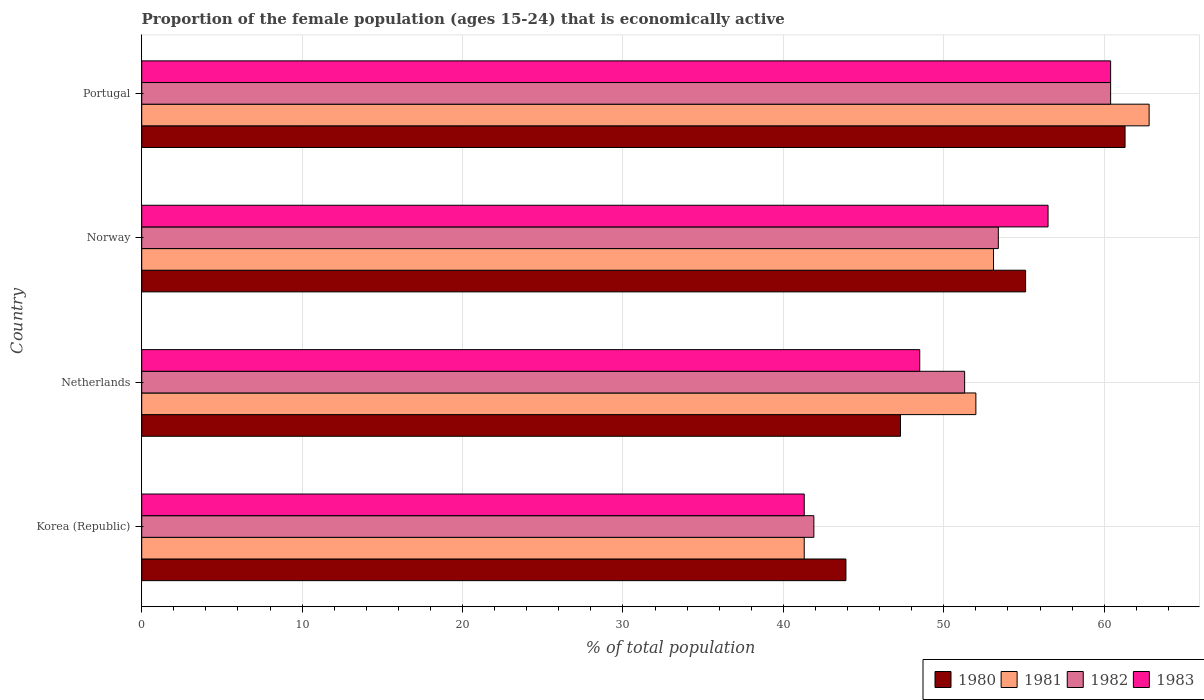How many different coloured bars are there?
Offer a very short reply. 4. Are the number of bars on each tick of the Y-axis equal?
Give a very brief answer. Yes. How many bars are there on the 3rd tick from the top?
Offer a very short reply. 4. What is the label of the 4th group of bars from the top?
Offer a terse response. Korea (Republic). In how many cases, is the number of bars for a given country not equal to the number of legend labels?
Give a very brief answer. 0. What is the proportion of the female population that is economically active in 1982 in Netherlands?
Provide a succinct answer. 51.3. Across all countries, what is the maximum proportion of the female population that is economically active in 1983?
Keep it short and to the point. 60.4. Across all countries, what is the minimum proportion of the female population that is economically active in 1983?
Provide a succinct answer. 41.3. In which country was the proportion of the female population that is economically active in 1981 maximum?
Provide a short and direct response. Portugal. In which country was the proportion of the female population that is economically active in 1980 minimum?
Give a very brief answer. Korea (Republic). What is the total proportion of the female population that is economically active in 1983 in the graph?
Ensure brevity in your answer.  206.7. What is the difference between the proportion of the female population that is economically active in 1983 in Korea (Republic) and that in Netherlands?
Offer a terse response. -7.2. What is the difference between the proportion of the female population that is economically active in 1981 in Portugal and the proportion of the female population that is economically active in 1980 in Korea (Republic)?
Provide a short and direct response. 18.9. What is the average proportion of the female population that is economically active in 1981 per country?
Give a very brief answer. 52.3. What is the difference between the proportion of the female population that is economically active in 1982 and proportion of the female population that is economically active in 1981 in Norway?
Your answer should be compact. 0.3. What is the ratio of the proportion of the female population that is economically active in 1981 in Norway to that in Portugal?
Ensure brevity in your answer.  0.85. Is the proportion of the female population that is economically active in 1980 in Korea (Republic) less than that in Norway?
Provide a short and direct response. Yes. What is the difference between the highest and the second highest proportion of the female population that is economically active in 1980?
Give a very brief answer. 6.2. In how many countries, is the proportion of the female population that is economically active in 1983 greater than the average proportion of the female population that is economically active in 1983 taken over all countries?
Offer a very short reply. 2. What does the 1st bar from the top in Korea (Republic) represents?
Provide a short and direct response. 1983. What does the 2nd bar from the bottom in Portugal represents?
Ensure brevity in your answer.  1981. Is it the case that in every country, the sum of the proportion of the female population that is economically active in 1981 and proportion of the female population that is economically active in 1983 is greater than the proportion of the female population that is economically active in 1980?
Provide a succinct answer. Yes. Are all the bars in the graph horizontal?
Your answer should be very brief. Yes. What is the difference between two consecutive major ticks on the X-axis?
Ensure brevity in your answer.  10. Does the graph contain any zero values?
Your answer should be very brief. No. Where does the legend appear in the graph?
Provide a succinct answer. Bottom right. How many legend labels are there?
Offer a very short reply. 4. How are the legend labels stacked?
Provide a short and direct response. Horizontal. What is the title of the graph?
Keep it short and to the point. Proportion of the female population (ages 15-24) that is economically active. Does "2010" appear as one of the legend labels in the graph?
Provide a short and direct response. No. What is the label or title of the X-axis?
Provide a short and direct response. % of total population. What is the % of total population in 1980 in Korea (Republic)?
Your answer should be compact. 43.9. What is the % of total population in 1981 in Korea (Republic)?
Offer a very short reply. 41.3. What is the % of total population of 1982 in Korea (Republic)?
Your response must be concise. 41.9. What is the % of total population in 1983 in Korea (Republic)?
Your answer should be compact. 41.3. What is the % of total population of 1980 in Netherlands?
Provide a succinct answer. 47.3. What is the % of total population in 1982 in Netherlands?
Your answer should be very brief. 51.3. What is the % of total population in 1983 in Netherlands?
Offer a terse response. 48.5. What is the % of total population in 1980 in Norway?
Keep it short and to the point. 55.1. What is the % of total population in 1981 in Norway?
Provide a short and direct response. 53.1. What is the % of total population in 1982 in Norway?
Keep it short and to the point. 53.4. What is the % of total population in 1983 in Norway?
Your response must be concise. 56.5. What is the % of total population in 1980 in Portugal?
Make the answer very short. 61.3. What is the % of total population in 1981 in Portugal?
Offer a very short reply. 62.8. What is the % of total population in 1982 in Portugal?
Provide a short and direct response. 60.4. What is the % of total population of 1983 in Portugal?
Provide a succinct answer. 60.4. Across all countries, what is the maximum % of total population of 1980?
Your response must be concise. 61.3. Across all countries, what is the maximum % of total population of 1981?
Make the answer very short. 62.8. Across all countries, what is the maximum % of total population in 1982?
Offer a terse response. 60.4. Across all countries, what is the maximum % of total population of 1983?
Ensure brevity in your answer.  60.4. Across all countries, what is the minimum % of total population in 1980?
Give a very brief answer. 43.9. Across all countries, what is the minimum % of total population in 1981?
Offer a terse response. 41.3. Across all countries, what is the minimum % of total population in 1982?
Ensure brevity in your answer.  41.9. Across all countries, what is the minimum % of total population of 1983?
Keep it short and to the point. 41.3. What is the total % of total population in 1980 in the graph?
Provide a succinct answer. 207.6. What is the total % of total population in 1981 in the graph?
Keep it short and to the point. 209.2. What is the total % of total population in 1982 in the graph?
Provide a succinct answer. 207. What is the total % of total population in 1983 in the graph?
Provide a succinct answer. 206.7. What is the difference between the % of total population of 1980 in Korea (Republic) and that in Netherlands?
Offer a terse response. -3.4. What is the difference between the % of total population in 1981 in Korea (Republic) and that in Netherlands?
Provide a succinct answer. -10.7. What is the difference between the % of total population in 1982 in Korea (Republic) and that in Netherlands?
Provide a short and direct response. -9.4. What is the difference between the % of total population of 1983 in Korea (Republic) and that in Netherlands?
Keep it short and to the point. -7.2. What is the difference between the % of total population in 1981 in Korea (Republic) and that in Norway?
Give a very brief answer. -11.8. What is the difference between the % of total population of 1983 in Korea (Republic) and that in Norway?
Your answer should be very brief. -15.2. What is the difference between the % of total population of 1980 in Korea (Republic) and that in Portugal?
Ensure brevity in your answer.  -17.4. What is the difference between the % of total population of 1981 in Korea (Republic) and that in Portugal?
Ensure brevity in your answer.  -21.5. What is the difference between the % of total population in 1982 in Korea (Republic) and that in Portugal?
Give a very brief answer. -18.5. What is the difference between the % of total population in 1983 in Korea (Republic) and that in Portugal?
Keep it short and to the point. -19.1. What is the difference between the % of total population of 1980 in Netherlands and that in Norway?
Offer a terse response. -7.8. What is the difference between the % of total population of 1981 in Netherlands and that in Norway?
Ensure brevity in your answer.  -1.1. What is the difference between the % of total population in 1982 in Netherlands and that in Norway?
Your answer should be very brief. -2.1. What is the difference between the % of total population in 1983 in Netherlands and that in Norway?
Give a very brief answer. -8. What is the difference between the % of total population of 1980 in Netherlands and that in Portugal?
Offer a terse response. -14. What is the difference between the % of total population of 1982 in Netherlands and that in Portugal?
Offer a very short reply. -9.1. What is the difference between the % of total population in 1983 in Netherlands and that in Portugal?
Your answer should be compact. -11.9. What is the difference between the % of total population of 1980 in Norway and that in Portugal?
Your response must be concise. -6.2. What is the difference between the % of total population of 1981 in Norway and that in Portugal?
Offer a terse response. -9.7. What is the difference between the % of total population in 1983 in Norway and that in Portugal?
Keep it short and to the point. -3.9. What is the difference between the % of total population in 1980 in Korea (Republic) and the % of total population in 1982 in Netherlands?
Provide a succinct answer. -7.4. What is the difference between the % of total population in 1982 in Korea (Republic) and the % of total population in 1983 in Netherlands?
Your answer should be very brief. -6.6. What is the difference between the % of total population in 1980 in Korea (Republic) and the % of total population in 1982 in Norway?
Offer a very short reply. -9.5. What is the difference between the % of total population of 1980 in Korea (Republic) and the % of total population of 1983 in Norway?
Offer a very short reply. -12.6. What is the difference between the % of total population of 1981 in Korea (Republic) and the % of total population of 1983 in Norway?
Your answer should be compact. -15.2. What is the difference between the % of total population of 1982 in Korea (Republic) and the % of total population of 1983 in Norway?
Offer a terse response. -14.6. What is the difference between the % of total population in 1980 in Korea (Republic) and the % of total population in 1981 in Portugal?
Offer a terse response. -18.9. What is the difference between the % of total population of 1980 in Korea (Republic) and the % of total population of 1982 in Portugal?
Offer a very short reply. -16.5. What is the difference between the % of total population in 1980 in Korea (Republic) and the % of total population in 1983 in Portugal?
Give a very brief answer. -16.5. What is the difference between the % of total population in 1981 in Korea (Republic) and the % of total population in 1982 in Portugal?
Your answer should be very brief. -19.1. What is the difference between the % of total population of 1981 in Korea (Republic) and the % of total population of 1983 in Portugal?
Your response must be concise. -19.1. What is the difference between the % of total population in 1982 in Korea (Republic) and the % of total population in 1983 in Portugal?
Give a very brief answer. -18.5. What is the difference between the % of total population in 1980 in Netherlands and the % of total population in 1982 in Norway?
Provide a short and direct response. -6.1. What is the difference between the % of total population of 1980 in Netherlands and the % of total population of 1981 in Portugal?
Provide a succinct answer. -15.5. What is the difference between the % of total population of 1980 in Netherlands and the % of total population of 1982 in Portugal?
Ensure brevity in your answer.  -13.1. What is the difference between the % of total population of 1980 in Netherlands and the % of total population of 1983 in Portugal?
Your answer should be compact. -13.1. What is the difference between the % of total population of 1980 in Norway and the % of total population of 1982 in Portugal?
Your answer should be very brief. -5.3. What is the difference between the % of total population in 1982 in Norway and the % of total population in 1983 in Portugal?
Offer a terse response. -7. What is the average % of total population in 1980 per country?
Provide a succinct answer. 51.9. What is the average % of total population in 1981 per country?
Offer a terse response. 52.3. What is the average % of total population of 1982 per country?
Provide a succinct answer. 51.75. What is the average % of total population of 1983 per country?
Ensure brevity in your answer.  51.67. What is the difference between the % of total population of 1980 and % of total population of 1983 in Korea (Republic)?
Offer a very short reply. 2.6. What is the difference between the % of total population of 1981 and % of total population of 1982 in Korea (Republic)?
Offer a terse response. -0.6. What is the difference between the % of total population of 1982 and % of total population of 1983 in Korea (Republic)?
Provide a succinct answer. 0.6. What is the difference between the % of total population of 1980 and % of total population of 1981 in Norway?
Ensure brevity in your answer.  2. What is the difference between the % of total population of 1980 and % of total population of 1982 in Norway?
Your answer should be very brief. 1.7. What is the difference between the % of total population of 1980 and % of total population of 1983 in Norway?
Make the answer very short. -1.4. What is the difference between the % of total population in 1981 and % of total population in 1983 in Norway?
Ensure brevity in your answer.  -3.4. What is the difference between the % of total population of 1980 and % of total population of 1981 in Portugal?
Provide a succinct answer. -1.5. What is the difference between the % of total population in 1981 and % of total population in 1982 in Portugal?
Your answer should be compact. 2.4. What is the difference between the % of total population of 1981 and % of total population of 1983 in Portugal?
Give a very brief answer. 2.4. What is the ratio of the % of total population of 1980 in Korea (Republic) to that in Netherlands?
Make the answer very short. 0.93. What is the ratio of the % of total population in 1981 in Korea (Republic) to that in Netherlands?
Offer a terse response. 0.79. What is the ratio of the % of total population in 1982 in Korea (Republic) to that in Netherlands?
Offer a terse response. 0.82. What is the ratio of the % of total population in 1983 in Korea (Republic) to that in Netherlands?
Offer a terse response. 0.85. What is the ratio of the % of total population of 1980 in Korea (Republic) to that in Norway?
Offer a very short reply. 0.8. What is the ratio of the % of total population of 1982 in Korea (Republic) to that in Norway?
Keep it short and to the point. 0.78. What is the ratio of the % of total population in 1983 in Korea (Republic) to that in Norway?
Keep it short and to the point. 0.73. What is the ratio of the % of total population of 1980 in Korea (Republic) to that in Portugal?
Offer a very short reply. 0.72. What is the ratio of the % of total population of 1981 in Korea (Republic) to that in Portugal?
Give a very brief answer. 0.66. What is the ratio of the % of total population in 1982 in Korea (Republic) to that in Portugal?
Offer a very short reply. 0.69. What is the ratio of the % of total population of 1983 in Korea (Republic) to that in Portugal?
Offer a very short reply. 0.68. What is the ratio of the % of total population of 1980 in Netherlands to that in Norway?
Keep it short and to the point. 0.86. What is the ratio of the % of total population of 1981 in Netherlands to that in Norway?
Offer a terse response. 0.98. What is the ratio of the % of total population of 1982 in Netherlands to that in Norway?
Offer a very short reply. 0.96. What is the ratio of the % of total population of 1983 in Netherlands to that in Norway?
Provide a succinct answer. 0.86. What is the ratio of the % of total population of 1980 in Netherlands to that in Portugal?
Your response must be concise. 0.77. What is the ratio of the % of total population in 1981 in Netherlands to that in Portugal?
Provide a succinct answer. 0.83. What is the ratio of the % of total population of 1982 in Netherlands to that in Portugal?
Make the answer very short. 0.85. What is the ratio of the % of total population in 1983 in Netherlands to that in Portugal?
Provide a short and direct response. 0.8. What is the ratio of the % of total population of 1980 in Norway to that in Portugal?
Your response must be concise. 0.9. What is the ratio of the % of total population in 1981 in Norway to that in Portugal?
Give a very brief answer. 0.85. What is the ratio of the % of total population in 1982 in Norway to that in Portugal?
Make the answer very short. 0.88. What is the ratio of the % of total population of 1983 in Norway to that in Portugal?
Your response must be concise. 0.94. What is the difference between the highest and the second highest % of total population in 1982?
Give a very brief answer. 7. What is the difference between the highest and the lowest % of total population in 1980?
Make the answer very short. 17.4. What is the difference between the highest and the lowest % of total population in 1982?
Provide a short and direct response. 18.5. 